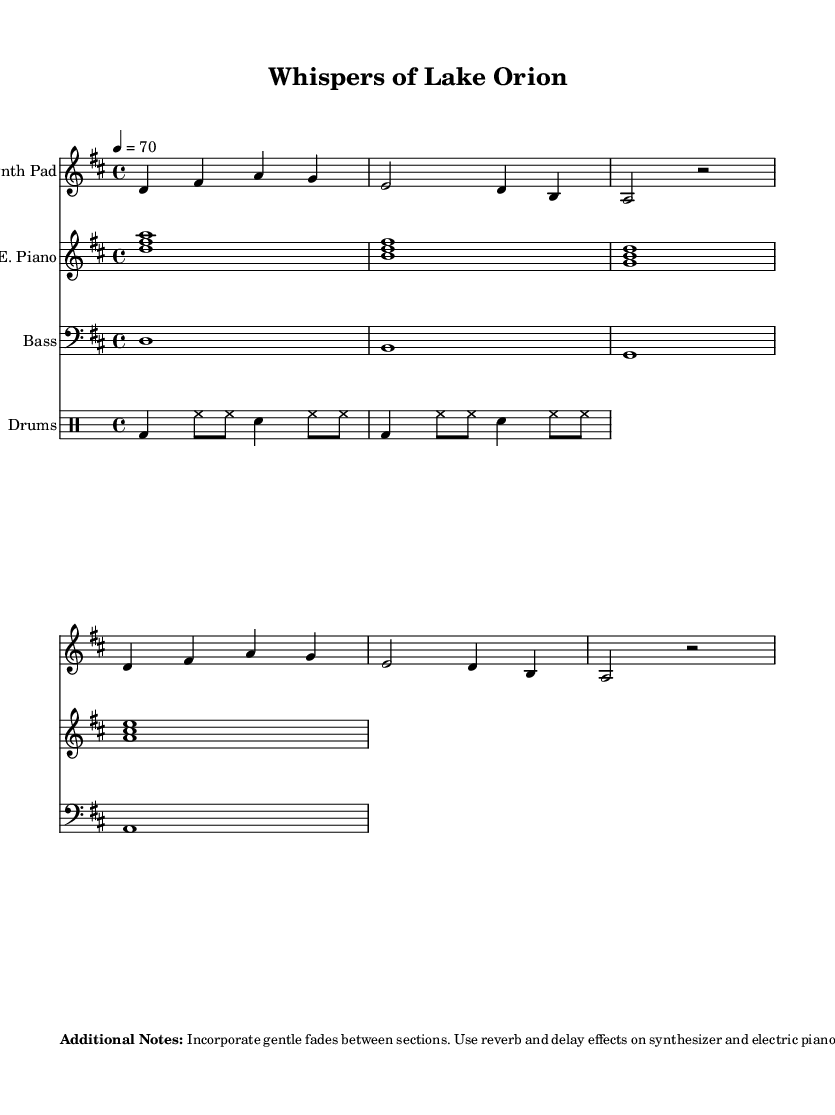What is the key signature of this music? The key signature is D major, which is indicated by the presence of two sharps.
Answer: D major What is the time signature of this music? The time signature is 4/4, shown at the beginning of the score.
Answer: 4/4 What is the tempo marking of this piece? The tempo marking is indicated as 70 beats per minute.
Answer: 70 How many measures are in the synth pad part? The synth pad part contains six measures, as observed in the notation.
Answer: Six measures What is the instrument used for the bass line? The bass line is played on a bass instrument, as indicated by the staff designation.
Answer: Bass What is the primary role of birdsong recordings in this piece? The birdsong recordings are used to create a tranquil atmosphere and are continuous throughout the music.
Answer: Create tranquility How does the drum pattern contribute to the overall feel of the piece? The drum pattern provides a gentle rhythm that complements the downtempo nature of the piece, enhancing its soothing quality.
Answer: Gentle rhythm 